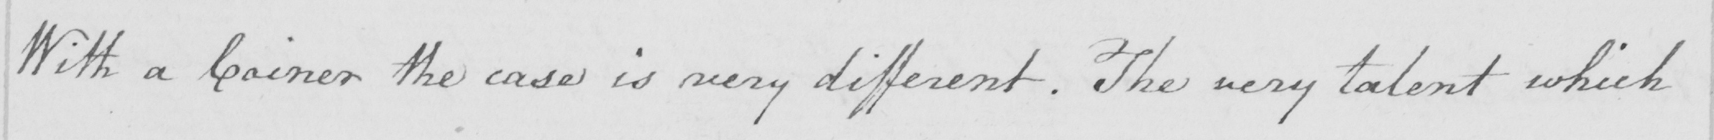Can you tell me what this handwritten text says? With a Coiner the case is very different . The very talent which 